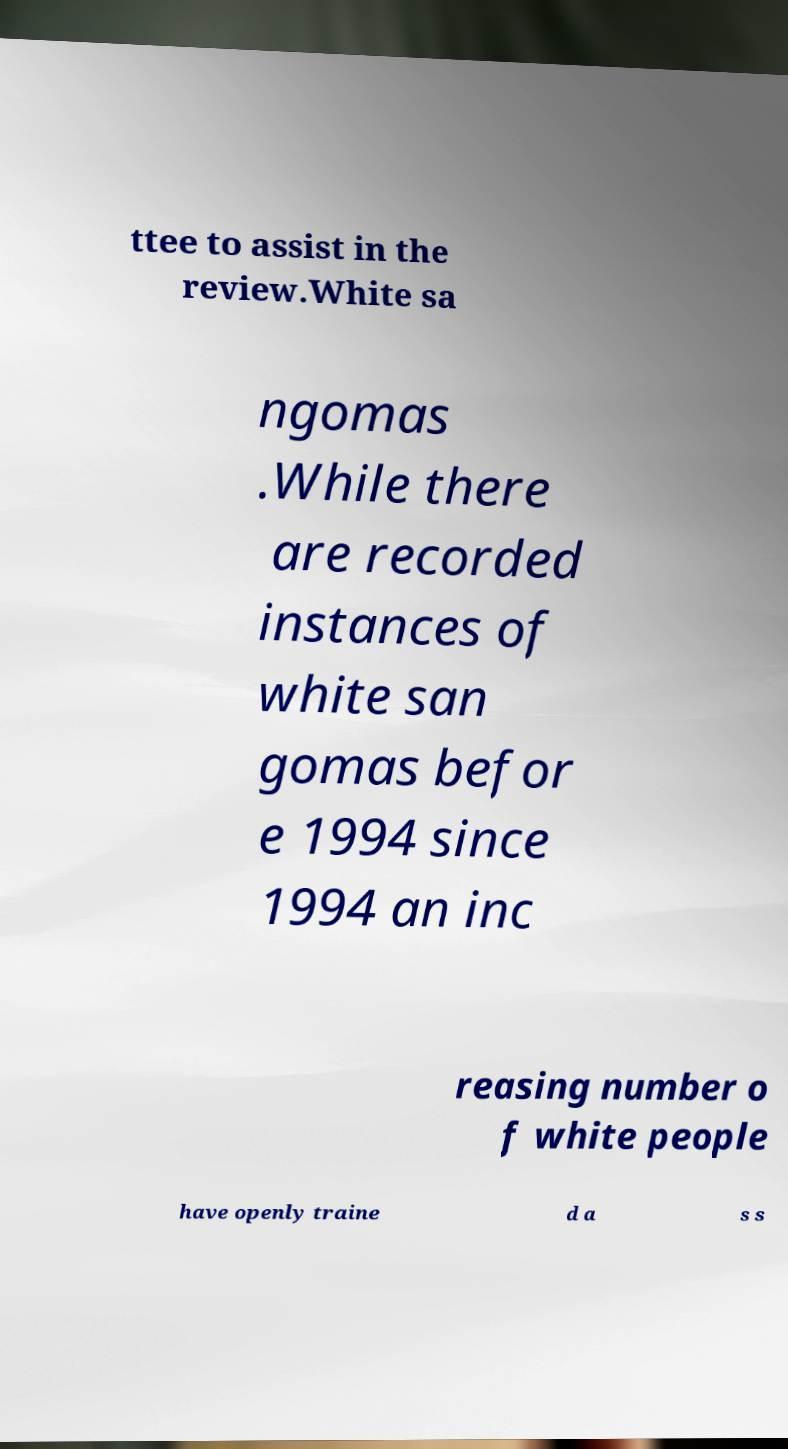Could you assist in decoding the text presented in this image and type it out clearly? ttee to assist in the review.White sa ngomas .While there are recorded instances of white san gomas befor e 1994 since 1994 an inc reasing number o f white people have openly traine d a s s 